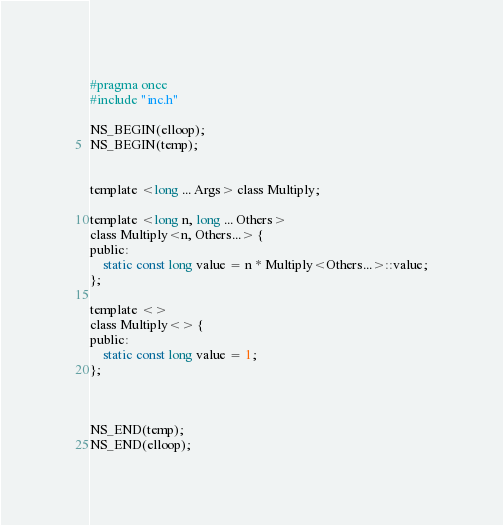<code> <loc_0><loc_0><loc_500><loc_500><_C_>#pragma once
#include "inc.h"

NS_BEGIN(elloop);
NS_BEGIN(temp);


template <long ... Args> class Multiply;

template <long n, long ... Others>
class Multiply<n, Others...> {
public:
    static const long value = n * Multiply<Others...>::value;
};

template <>
class Multiply<> {
public:
    static const long value = 1;
};



NS_END(temp);
NS_END(elloop);</code> 